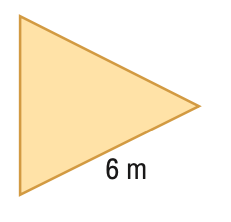Question: Find the area of the regular polygon. Round to the nearest tenth.
Choices:
A. 15.6
B. 18.0
C. 31.2
D. 36.0
Answer with the letter. Answer: A 